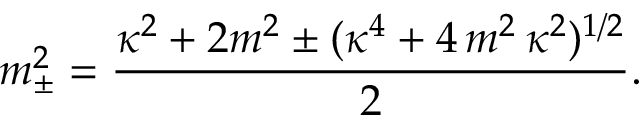<formula> <loc_0><loc_0><loc_500><loc_500>m _ { \pm } ^ { 2 } = \frac { \kappa ^ { 2 } + 2 m ^ { 2 } \pm ( \kappa ^ { 4 } + 4 \, m ^ { 2 } \, \kappa ^ { 2 } ) ^ { 1 / 2 } } { 2 } .</formula> 